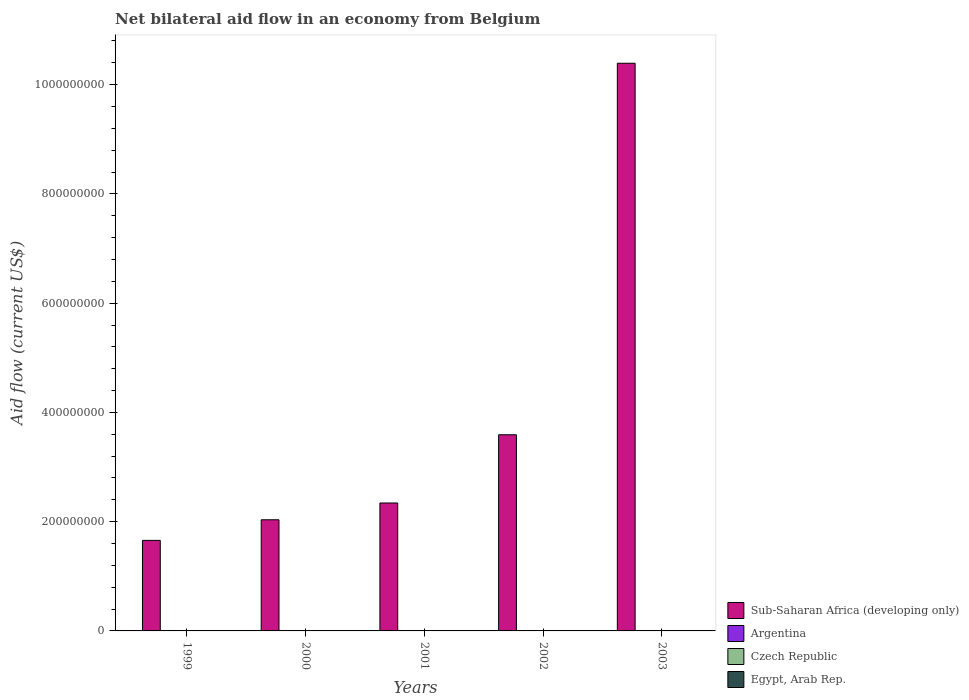How many different coloured bars are there?
Your answer should be compact. 4. Are the number of bars per tick equal to the number of legend labels?
Give a very brief answer. No. How many bars are there on the 4th tick from the left?
Your answer should be very brief. 3. How many bars are there on the 1st tick from the right?
Your answer should be compact. 3. What is the label of the 1st group of bars from the left?
Keep it short and to the point. 1999. What is the net bilateral aid flow in Egypt, Arab Rep. in 2000?
Ensure brevity in your answer.  10000. Across all years, what is the maximum net bilateral aid flow in Czech Republic?
Your answer should be compact. 5.80e+05. Across all years, what is the minimum net bilateral aid flow in Sub-Saharan Africa (developing only)?
Offer a very short reply. 1.66e+08. In which year was the net bilateral aid flow in Sub-Saharan Africa (developing only) maximum?
Give a very brief answer. 2003. What is the total net bilateral aid flow in Czech Republic in the graph?
Provide a succinct answer. 2.14e+06. What is the difference between the net bilateral aid flow in Sub-Saharan Africa (developing only) in 2000 and the net bilateral aid flow in Argentina in 2003?
Make the answer very short. 2.03e+08. What is the average net bilateral aid flow in Argentina per year?
Provide a succinct answer. 5.02e+05. In the year 2002, what is the difference between the net bilateral aid flow in Argentina and net bilateral aid flow in Czech Republic?
Offer a very short reply. -6.00e+04. In how many years, is the net bilateral aid flow in Czech Republic greater than 520000000 US$?
Your response must be concise. 0. What is the ratio of the net bilateral aid flow in Czech Republic in 1999 to that in 2001?
Give a very brief answer. 1.22. What is the difference between the highest and the second highest net bilateral aid flow in Argentina?
Provide a succinct answer. 2.40e+05. What is the difference between the highest and the lowest net bilateral aid flow in Egypt, Arab Rep.?
Keep it short and to the point. 2.00e+04. In how many years, is the net bilateral aid flow in Egypt, Arab Rep. greater than the average net bilateral aid flow in Egypt, Arab Rep. taken over all years?
Provide a succinct answer. 3. Is it the case that in every year, the sum of the net bilateral aid flow in Sub-Saharan Africa (developing only) and net bilateral aid flow in Argentina is greater than the sum of net bilateral aid flow in Czech Republic and net bilateral aid flow in Egypt, Arab Rep.?
Your answer should be very brief. Yes. How many bars are there?
Your response must be concise. 18. How many years are there in the graph?
Your response must be concise. 5. What is the difference between two consecutive major ticks on the Y-axis?
Provide a short and direct response. 2.00e+08. Does the graph contain any zero values?
Provide a succinct answer. Yes. How are the legend labels stacked?
Your response must be concise. Vertical. What is the title of the graph?
Your response must be concise. Net bilateral aid flow in an economy from Belgium. What is the label or title of the X-axis?
Your answer should be compact. Years. What is the Aid flow (current US$) of Sub-Saharan Africa (developing only) in 1999?
Keep it short and to the point. 1.66e+08. What is the Aid flow (current US$) in Argentina in 1999?
Provide a short and direct response. 7.80e+05. What is the Aid flow (current US$) in Czech Republic in 1999?
Offer a very short reply. 4.40e+05. What is the Aid flow (current US$) of Egypt, Arab Rep. in 1999?
Your answer should be compact. 2.00e+04. What is the Aid flow (current US$) in Sub-Saharan Africa (developing only) in 2000?
Offer a very short reply. 2.03e+08. What is the Aid flow (current US$) of Argentina in 2000?
Your response must be concise. 5.40e+05. What is the Aid flow (current US$) of Czech Republic in 2000?
Keep it short and to the point. 3.80e+05. What is the Aid flow (current US$) in Sub-Saharan Africa (developing only) in 2001?
Your answer should be compact. 2.34e+08. What is the Aid flow (current US$) of Argentina in 2001?
Keep it short and to the point. 4.80e+05. What is the Aid flow (current US$) in Czech Republic in 2001?
Your answer should be compact. 3.60e+05. What is the Aid flow (current US$) in Egypt, Arab Rep. in 2001?
Provide a succinct answer. 10000. What is the Aid flow (current US$) in Sub-Saharan Africa (developing only) in 2002?
Offer a terse response. 3.59e+08. What is the Aid flow (current US$) of Argentina in 2002?
Ensure brevity in your answer.  3.20e+05. What is the Aid flow (current US$) of Sub-Saharan Africa (developing only) in 2003?
Offer a very short reply. 1.04e+09. What is the Aid flow (current US$) in Argentina in 2003?
Keep it short and to the point. 3.90e+05. What is the Aid flow (current US$) of Czech Republic in 2003?
Provide a succinct answer. 5.80e+05. What is the Aid flow (current US$) in Egypt, Arab Rep. in 2003?
Make the answer very short. 0. Across all years, what is the maximum Aid flow (current US$) in Sub-Saharan Africa (developing only)?
Make the answer very short. 1.04e+09. Across all years, what is the maximum Aid flow (current US$) in Argentina?
Provide a succinct answer. 7.80e+05. Across all years, what is the maximum Aid flow (current US$) in Czech Republic?
Make the answer very short. 5.80e+05. Across all years, what is the maximum Aid flow (current US$) of Egypt, Arab Rep.?
Provide a short and direct response. 2.00e+04. Across all years, what is the minimum Aid flow (current US$) of Sub-Saharan Africa (developing only)?
Provide a short and direct response. 1.66e+08. What is the total Aid flow (current US$) of Sub-Saharan Africa (developing only) in the graph?
Offer a terse response. 2.00e+09. What is the total Aid flow (current US$) of Argentina in the graph?
Your response must be concise. 2.51e+06. What is the total Aid flow (current US$) of Czech Republic in the graph?
Your response must be concise. 2.14e+06. What is the total Aid flow (current US$) in Egypt, Arab Rep. in the graph?
Your response must be concise. 4.00e+04. What is the difference between the Aid flow (current US$) of Sub-Saharan Africa (developing only) in 1999 and that in 2000?
Give a very brief answer. -3.77e+07. What is the difference between the Aid flow (current US$) in Sub-Saharan Africa (developing only) in 1999 and that in 2001?
Provide a short and direct response. -6.85e+07. What is the difference between the Aid flow (current US$) in Argentina in 1999 and that in 2001?
Keep it short and to the point. 3.00e+05. What is the difference between the Aid flow (current US$) of Czech Republic in 1999 and that in 2001?
Give a very brief answer. 8.00e+04. What is the difference between the Aid flow (current US$) of Sub-Saharan Africa (developing only) in 1999 and that in 2002?
Your answer should be very brief. -1.93e+08. What is the difference between the Aid flow (current US$) in Argentina in 1999 and that in 2002?
Offer a terse response. 4.60e+05. What is the difference between the Aid flow (current US$) of Sub-Saharan Africa (developing only) in 1999 and that in 2003?
Your response must be concise. -8.73e+08. What is the difference between the Aid flow (current US$) in Argentina in 1999 and that in 2003?
Your answer should be very brief. 3.90e+05. What is the difference between the Aid flow (current US$) in Sub-Saharan Africa (developing only) in 2000 and that in 2001?
Your answer should be very brief. -3.07e+07. What is the difference between the Aid flow (current US$) in Argentina in 2000 and that in 2001?
Provide a short and direct response. 6.00e+04. What is the difference between the Aid flow (current US$) in Sub-Saharan Africa (developing only) in 2000 and that in 2002?
Provide a short and direct response. -1.56e+08. What is the difference between the Aid flow (current US$) of Czech Republic in 2000 and that in 2002?
Provide a succinct answer. 0. What is the difference between the Aid flow (current US$) in Sub-Saharan Africa (developing only) in 2000 and that in 2003?
Make the answer very short. -8.36e+08. What is the difference between the Aid flow (current US$) in Czech Republic in 2000 and that in 2003?
Offer a terse response. -2.00e+05. What is the difference between the Aid flow (current US$) in Sub-Saharan Africa (developing only) in 2001 and that in 2002?
Make the answer very short. -1.25e+08. What is the difference between the Aid flow (current US$) in Argentina in 2001 and that in 2002?
Give a very brief answer. 1.60e+05. What is the difference between the Aid flow (current US$) of Sub-Saharan Africa (developing only) in 2001 and that in 2003?
Ensure brevity in your answer.  -8.05e+08. What is the difference between the Aid flow (current US$) of Argentina in 2001 and that in 2003?
Provide a short and direct response. 9.00e+04. What is the difference between the Aid flow (current US$) in Sub-Saharan Africa (developing only) in 2002 and that in 2003?
Offer a terse response. -6.80e+08. What is the difference between the Aid flow (current US$) of Argentina in 2002 and that in 2003?
Your response must be concise. -7.00e+04. What is the difference between the Aid flow (current US$) of Sub-Saharan Africa (developing only) in 1999 and the Aid flow (current US$) of Argentina in 2000?
Offer a terse response. 1.65e+08. What is the difference between the Aid flow (current US$) of Sub-Saharan Africa (developing only) in 1999 and the Aid flow (current US$) of Czech Republic in 2000?
Provide a short and direct response. 1.65e+08. What is the difference between the Aid flow (current US$) of Sub-Saharan Africa (developing only) in 1999 and the Aid flow (current US$) of Egypt, Arab Rep. in 2000?
Give a very brief answer. 1.66e+08. What is the difference between the Aid flow (current US$) in Argentina in 1999 and the Aid flow (current US$) in Czech Republic in 2000?
Offer a terse response. 4.00e+05. What is the difference between the Aid flow (current US$) of Argentina in 1999 and the Aid flow (current US$) of Egypt, Arab Rep. in 2000?
Give a very brief answer. 7.70e+05. What is the difference between the Aid flow (current US$) of Sub-Saharan Africa (developing only) in 1999 and the Aid flow (current US$) of Argentina in 2001?
Ensure brevity in your answer.  1.65e+08. What is the difference between the Aid flow (current US$) in Sub-Saharan Africa (developing only) in 1999 and the Aid flow (current US$) in Czech Republic in 2001?
Ensure brevity in your answer.  1.65e+08. What is the difference between the Aid flow (current US$) of Sub-Saharan Africa (developing only) in 1999 and the Aid flow (current US$) of Egypt, Arab Rep. in 2001?
Provide a short and direct response. 1.66e+08. What is the difference between the Aid flow (current US$) in Argentina in 1999 and the Aid flow (current US$) in Egypt, Arab Rep. in 2001?
Your answer should be very brief. 7.70e+05. What is the difference between the Aid flow (current US$) of Czech Republic in 1999 and the Aid flow (current US$) of Egypt, Arab Rep. in 2001?
Your response must be concise. 4.30e+05. What is the difference between the Aid flow (current US$) of Sub-Saharan Africa (developing only) in 1999 and the Aid flow (current US$) of Argentina in 2002?
Offer a terse response. 1.65e+08. What is the difference between the Aid flow (current US$) in Sub-Saharan Africa (developing only) in 1999 and the Aid flow (current US$) in Czech Republic in 2002?
Ensure brevity in your answer.  1.65e+08. What is the difference between the Aid flow (current US$) of Argentina in 1999 and the Aid flow (current US$) of Czech Republic in 2002?
Your response must be concise. 4.00e+05. What is the difference between the Aid flow (current US$) of Sub-Saharan Africa (developing only) in 1999 and the Aid flow (current US$) of Argentina in 2003?
Your answer should be very brief. 1.65e+08. What is the difference between the Aid flow (current US$) of Sub-Saharan Africa (developing only) in 1999 and the Aid flow (current US$) of Czech Republic in 2003?
Offer a very short reply. 1.65e+08. What is the difference between the Aid flow (current US$) in Argentina in 1999 and the Aid flow (current US$) in Czech Republic in 2003?
Make the answer very short. 2.00e+05. What is the difference between the Aid flow (current US$) of Sub-Saharan Africa (developing only) in 2000 and the Aid flow (current US$) of Argentina in 2001?
Give a very brief answer. 2.03e+08. What is the difference between the Aid flow (current US$) in Sub-Saharan Africa (developing only) in 2000 and the Aid flow (current US$) in Czech Republic in 2001?
Ensure brevity in your answer.  2.03e+08. What is the difference between the Aid flow (current US$) in Sub-Saharan Africa (developing only) in 2000 and the Aid flow (current US$) in Egypt, Arab Rep. in 2001?
Keep it short and to the point. 2.03e+08. What is the difference between the Aid flow (current US$) of Argentina in 2000 and the Aid flow (current US$) of Czech Republic in 2001?
Provide a succinct answer. 1.80e+05. What is the difference between the Aid flow (current US$) of Argentina in 2000 and the Aid flow (current US$) of Egypt, Arab Rep. in 2001?
Your response must be concise. 5.30e+05. What is the difference between the Aid flow (current US$) in Czech Republic in 2000 and the Aid flow (current US$) in Egypt, Arab Rep. in 2001?
Make the answer very short. 3.70e+05. What is the difference between the Aid flow (current US$) in Sub-Saharan Africa (developing only) in 2000 and the Aid flow (current US$) in Argentina in 2002?
Provide a succinct answer. 2.03e+08. What is the difference between the Aid flow (current US$) of Sub-Saharan Africa (developing only) in 2000 and the Aid flow (current US$) of Czech Republic in 2002?
Your response must be concise. 2.03e+08. What is the difference between the Aid flow (current US$) in Argentina in 2000 and the Aid flow (current US$) in Czech Republic in 2002?
Keep it short and to the point. 1.60e+05. What is the difference between the Aid flow (current US$) in Sub-Saharan Africa (developing only) in 2000 and the Aid flow (current US$) in Argentina in 2003?
Your answer should be compact. 2.03e+08. What is the difference between the Aid flow (current US$) of Sub-Saharan Africa (developing only) in 2000 and the Aid flow (current US$) of Czech Republic in 2003?
Offer a terse response. 2.03e+08. What is the difference between the Aid flow (current US$) in Sub-Saharan Africa (developing only) in 2001 and the Aid flow (current US$) in Argentina in 2002?
Your answer should be compact. 2.34e+08. What is the difference between the Aid flow (current US$) of Sub-Saharan Africa (developing only) in 2001 and the Aid flow (current US$) of Czech Republic in 2002?
Provide a short and direct response. 2.34e+08. What is the difference between the Aid flow (current US$) in Sub-Saharan Africa (developing only) in 2001 and the Aid flow (current US$) in Argentina in 2003?
Your answer should be very brief. 2.34e+08. What is the difference between the Aid flow (current US$) in Sub-Saharan Africa (developing only) in 2001 and the Aid flow (current US$) in Czech Republic in 2003?
Provide a short and direct response. 2.34e+08. What is the difference between the Aid flow (current US$) in Sub-Saharan Africa (developing only) in 2002 and the Aid flow (current US$) in Argentina in 2003?
Keep it short and to the point. 3.59e+08. What is the difference between the Aid flow (current US$) in Sub-Saharan Africa (developing only) in 2002 and the Aid flow (current US$) in Czech Republic in 2003?
Give a very brief answer. 3.59e+08. What is the difference between the Aid flow (current US$) of Argentina in 2002 and the Aid flow (current US$) of Czech Republic in 2003?
Make the answer very short. -2.60e+05. What is the average Aid flow (current US$) in Sub-Saharan Africa (developing only) per year?
Your answer should be compact. 4.00e+08. What is the average Aid flow (current US$) in Argentina per year?
Your answer should be compact. 5.02e+05. What is the average Aid flow (current US$) in Czech Republic per year?
Give a very brief answer. 4.28e+05. What is the average Aid flow (current US$) of Egypt, Arab Rep. per year?
Your answer should be compact. 8000. In the year 1999, what is the difference between the Aid flow (current US$) of Sub-Saharan Africa (developing only) and Aid flow (current US$) of Argentina?
Ensure brevity in your answer.  1.65e+08. In the year 1999, what is the difference between the Aid flow (current US$) in Sub-Saharan Africa (developing only) and Aid flow (current US$) in Czech Republic?
Offer a very short reply. 1.65e+08. In the year 1999, what is the difference between the Aid flow (current US$) in Sub-Saharan Africa (developing only) and Aid flow (current US$) in Egypt, Arab Rep.?
Your answer should be compact. 1.66e+08. In the year 1999, what is the difference between the Aid flow (current US$) of Argentina and Aid flow (current US$) of Egypt, Arab Rep.?
Provide a short and direct response. 7.60e+05. In the year 2000, what is the difference between the Aid flow (current US$) of Sub-Saharan Africa (developing only) and Aid flow (current US$) of Argentina?
Make the answer very short. 2.03e+08. In the year 2000, what is the difference between the Aid flow (current US$) in Sub-Saharan Africa (developing only) and Aid flow (current US$) in Czech Republic?
Your response must be concise. 2.03e+08. In the year 2000, what is the difference between the Aid flow (current US$) in Sub-Saharan Africa (developing only) and Aid flow (current US$) in Egypt, Arab Rep.?
Ensure brevity in your answer.  2.03e+08. In the year 2000, what is the difference between the Aid flow (current US$) of Argentina and Aid flow (current US$) of Czech Republic?
Your answer should be compact. 1.60e+05. In the year 2000, what is the difference between the Aid flow (current US$) of Argentina and Aid flow (current US$) of Egypt, Arab Rep.?
Provide a short and direct response. 5.30e+05. In the year 2000, what is the difference between the Aid flow (current US$) in Czech Republic and Aid flow (current US$) in Egypt, Arab Rep.?
Keep it short and to the point. 3.70e+05. In the year 2001, what is the difference between the Aid flow (current US$) of Sub-Saharan Africa (developing only) and Aid flow (current US$) of Argentina?
Your answer should be compact. 2.34e+08. In the year 2001, what is the difference between the Aid flow (current US$) of Sub-Saharan Africa (developing only) and Aid flow (current US$) of Czech Republic?
Your response must be concise. 2.34e+08. In the year 2001, what is the difference between the Aid flow (current US$) of Sub-Saharan Africa (developing only) and Aid flow (current US$) of Egypt, Arab Rep.?
Keep it short and to the point. 2.34e+08. In the year 2001, what is the difference between the Aid flow (current US$) in Argentina and Aid flow (current US$) in Egypt, Arab Rep.?
Your response must be concise. 4.70e+05. In the year 2001, what is the difference between the Aid flow (current US$) in Czech Republic and Aid flow (current US$) in Egypt, Arab Rep.?
Provide a succinct answer. 3.50e+05. In the year 2002, what is the difference between the Aid flow (current US$) in Sub-Saharan Africa (developing only) and Aid flow (current US$) in Argentina?
Your response must be concise. 3.59e+08. In the year 2002, what is the difference between the Aid flow (current US$) in Sub-Saharan Africa (developing only) and Aid flow (current US$) in Czech Republic?
Make the answer very short. 3.59e+08. In the year 2003, what is the difference between the Aid flow (current US$) in Sub-Saharan Africa (developing only) and Aid flow (current US$) in Argentina?
Provide a succinct answer. 1.04e+09. In the year 2003, what is the difference between the Aid flow (current US$) in Sub-Saharan Africa (developing only) and Aid flow (current US$) in Czech Republic?
Ensure brevity in your answer.  1.04e+09. What is the ratio of the Aid flow (current US$) in Sub-Saharan Africa (developing only) in 1999 to that in 2000?
Offer a very short reply. 0.81. What is the ratio of the Aid flow (current US$) of Argentina in 1999 to that in 2000?
Make the answer very short. 1.44. What is the ratio of the Aid flow (current US$) of Czech Republic in 1999 to that in 2000?
Provide a succinct answer. 1.16. What is the ratio of the Aid flow (current US$) of Sub-Saharan Africa (developing only) in 1999 to that in 2001?
Give a very brief answer. 0.71. What is the ratio of the Aid flow (current US$) of Argentina in 1999 to that in 2001?
Keep it short and to the point. 1.62. What is the ratio of the Aid flow (current US$) in Czech Republic in 1999 to that in 2001?
Ensure brevity in your answer.  1.22. What is the ratio of the Aid flow (current US$) in Sub-Saharan Africa (developing only) in 1999 to that in 2002?
Provide a short and direct response. 0.46. What is the ratio of the Aid flow (current US$) of Argentina in 1999 to that in 2002?
Offer a terse response. 2.44. What is the ratio of the Aid flow (current US$) of Czech Republic in 1999 to that in 2002?
Ensure brevity in your answer.  1.16. What is the ratio of the Aid flow (current US$) in Sub-Saharan Africa (developing only) in 1999 to that in 2003?
Ensure brevity in your answer.  0.16. What is the ratio of the Aid flow (current US$) of Argentina in 1999 to that in 2003?
Your answer should be very brief. 2. What is the ratio of the Aid flow (current US$) in Czech Republic in 1999 to that in 2003?
Ensure brevity in your answer.  0.76. What is the ratio of the Aid flow (current US$) of Sub-Saharan Africa (developing only) in 2000 to that in 2001?
Give a very brief answer. 0.87. What is the ratio of the Aid flow (current US$) of Argentina in 2000 to that in 2001?
Ensure brevity in your answer.  1.12. What is the ratio of the Aid flow (current US$) of Czech Republic in 2000 to that in 2001?
Provide a short and direct response. 1.06. What is the ratio of the Aid flow (current US$) of Sub-Saharan Africa (developing only) in 2000 to that in 2002?
Give a very brief answer. 0.57. What is the ratio of the Aid flow (current US$) of Argentina in 2000 to that in 2002?
Offer a terse response. 1.69. What is the ratio of the Aid flow (current US$) in Czech Republic in 2000 to that in 2002?
Offer a very short reply. 1. What is the ratio of the Aid flow (current US$) of Sub-Saharan Africa (developing only) in 2000 to that in 2003?
Your response must be concise. 0.2. What is the ratio of the Aid flow (current US$) of Argentina in 2000 to that in 2003?
Your answer should be very brief. 1.38. What is the ratio of the Aid flow (current US$) in Czech Republic in 2000 to that in 2003?
Give a very brief answer. 0.66. What is the ratio of the Aid flow (current US$) in Sub-Saharan Africa (developing only) in 2001 to that in 2002?
Your response must be concise. 0.65. What is the ratio of the Aid flow (current US$) of Czech Republic in 2001 to that in 2002?
Provide a succinct answer. 0.95. What is the ratio of the Aid flow (current US$) in Sub-Saharan Africa (developing only) in 2001 to that in 2003?
Provide a short and direct response. 0.23. What is the ratio of the Aid flow (current US$) of Argentina in 2001 to that in 2003?
Your response must be concise. 1.23. What is the ratio of the Aid flow (current US$) of Czech Republic in 2001 to that in 2003?
Give a very brief answer. 0.62. What is the ratio of the Aid flow (current US$) in Sub-Saharan Africa (developing only) in 2002 to that in 2003?
Your answer should be compact. 0.35. What is the ratio of the Aid flow (current US$) in Argentina in 2002 to that in 2003?
Provide a short and direct response. 0.82. What is the ratio of the Aid flow (current US$) of Czech Republic in 2002 to that in 2003?
Provide a succinct answer. 0.66. What is the difference between the highest and the second highest Aid flow (current US$) of Sub-Saharan Africa (developing only)?
Make the answer very short. 6.80e+08. What is the difference between the highest and the lowest Aid flow (current US$) in Sub-Saharan Africa (developing only)?
Offer a terse response. 8.73e+08. 